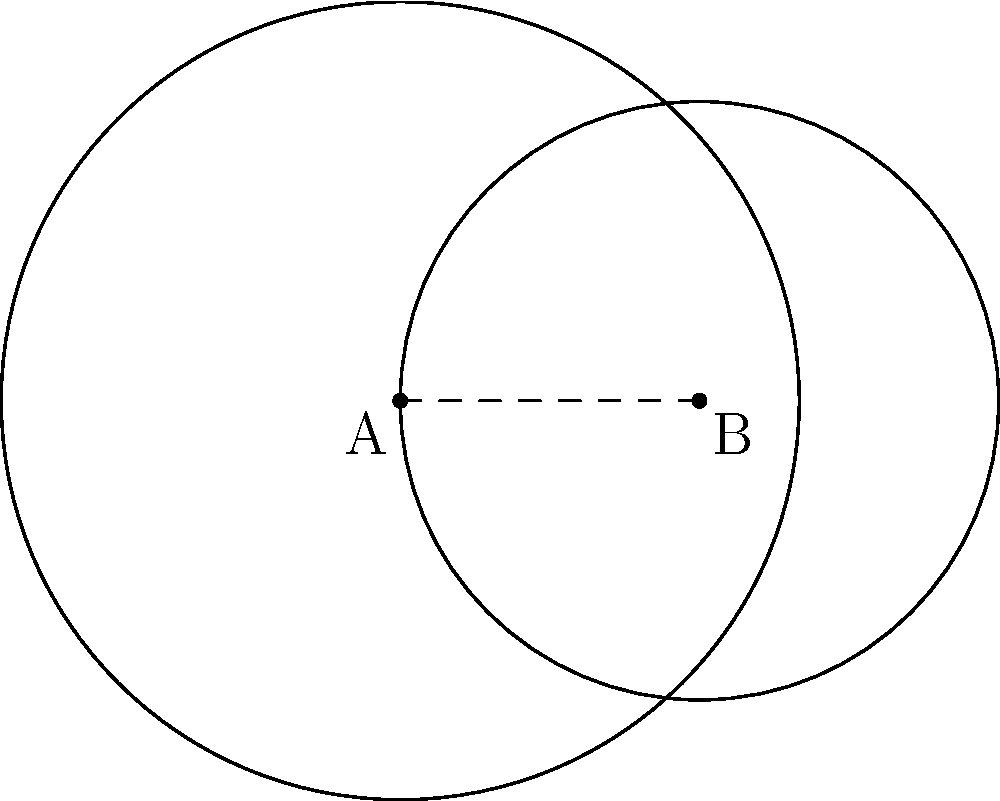In a clinical trial data privacy system, two overlapping confidentiality zones are represented by circular regions. Zone A has a radius of 4 units, and Zone B has a radius of 3 units. The centers of these zones are 3 units apart. Calculate the area of the overlapping region where patient data requires heightened security measures. Round your answer to two decimal places. To find the area of overlap between two circles, we can use the following steps:

1) First, we need to find the distance between the centers of the circles:
   $d = 3$ (given in the question)

2) The radii of the circles are:
   $r_1 = 4$ and $r_2 = 3$

3) To calculate the area of overlap, we use the formula:

   $A = r_1^2 \arccos(\frac{d^2 + r_1^2 - r_2^2}{2dr_1}) + r_2^2 \arccos(\frac{d^2 + r_2^2 - r_1^2}{2dr_2}) - \frac{1}{2}\sqrt{(-d+r_1+r_2)(d+r_1-r_2)(d-r_1+r_2)(d+r_1+r_2)}$

4) Substituting the values:

   $A = 4^2 \arccos(\frac{3^2 + 4^2 - 3^2}{2 \cdot 3 \cdot 4}) + 3^2 \arccos(\frac{3^2 + 3^2 - 4^2}{2 \cdot 3 \cdot 3}) - \frac{1}{2}\sqrt{(-3+4+3)(3+4-3)(3-4+3)(3+4+3)}$

5) Simplifying:

   $A = 16 \arccos(\frac{25}{24}) + 9 \arccos(\frac{10}{18}) - \frac{1}{2}\sqrt{4 \cdot 4 \cdot 2 \cdot 10}$

6) Calculating:

   $A \approx 16 \cdot 0.2731 + 9 \cdot 1.0742 - \frac{1}{2}\sqrt{320}$
   $A \approx 4.3696 + 9.6678 - 8.9443$
   $A \approx 5.0931$

7) Rounding to two decimal places:

   $A \approx 5.09$ square units
Answer: 5.09 square units 